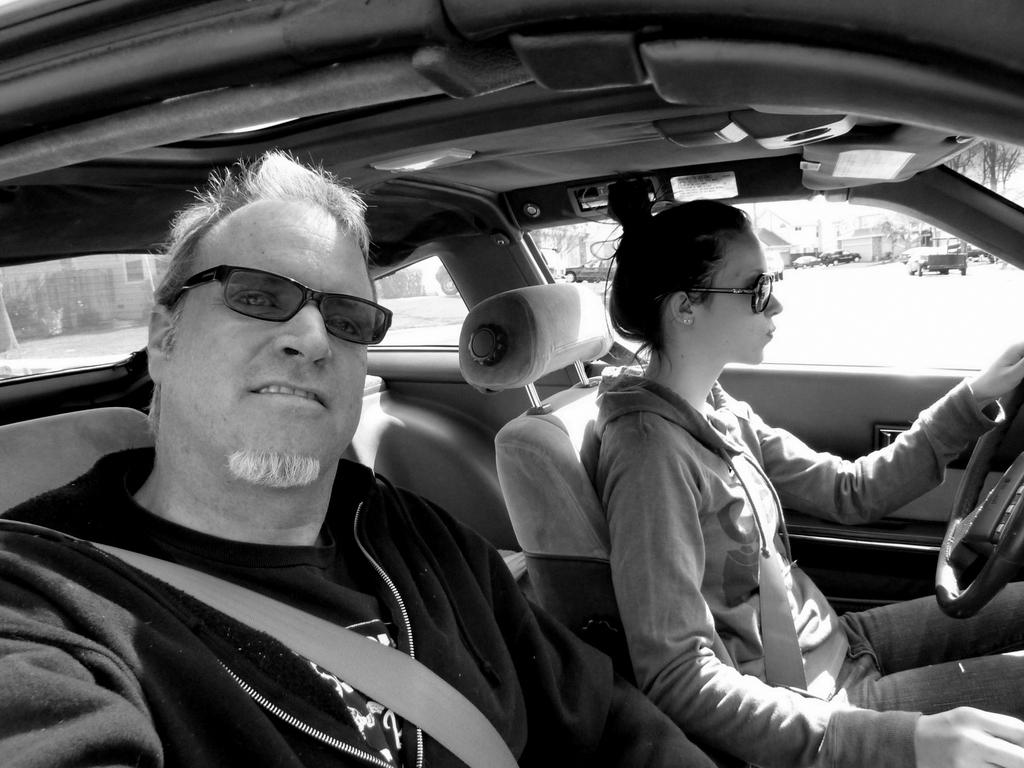How many people are in the car in the image? There are two people sitting in the car. What can be seen in the background of the image? There are vehicles, buildings, trees, and some unspecified objects in the background. What type of meal is the cook preparing in the image? There is no cook or meal preparation visible in the image. 